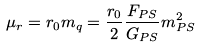<formula> <loc_0><loc_0><loc_500><loc_500>\mu _ { r } = r _ { 0 } m _ { q } = \frac { r _ { 0 } } { 2 } \frac { F _ { P S } } { G _ { P S } } m _ { P S } ^ { 2 }</formula> 